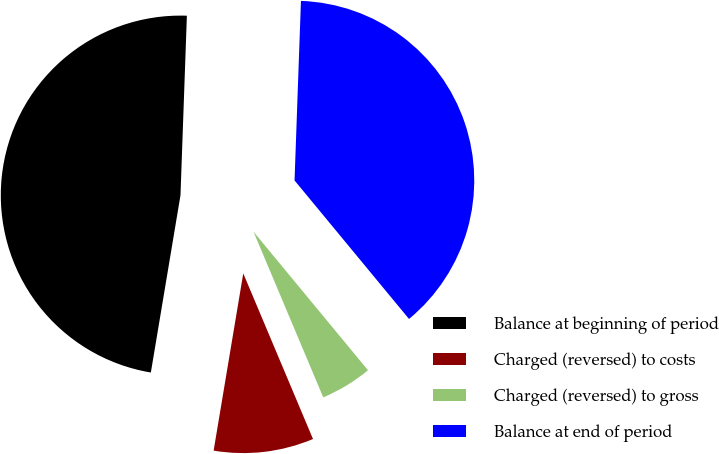Convert chart. <chart><loc_0><loc_0><loc_500><loc_500><pie_chart><fcel>Balance at beginning of period<fcel>Charged (reversed) to costs<fcel>Charged (reversed) to gross<fcel>Balance at end of period<nl><fcel>47.93%<fcel>8.98%<fcel>4.65%<fcel>38.44%<nl></chart> 